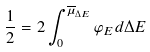Convert formula to latex. <formula><loc_0><loc_0><loc_500><loc_500>\frac { 1 } { 2 } = 2 \int _ { 0 } ^ { \overline { \mu } _ { \Delta E } } \varphi _ { E } d \Delta E</formula> 